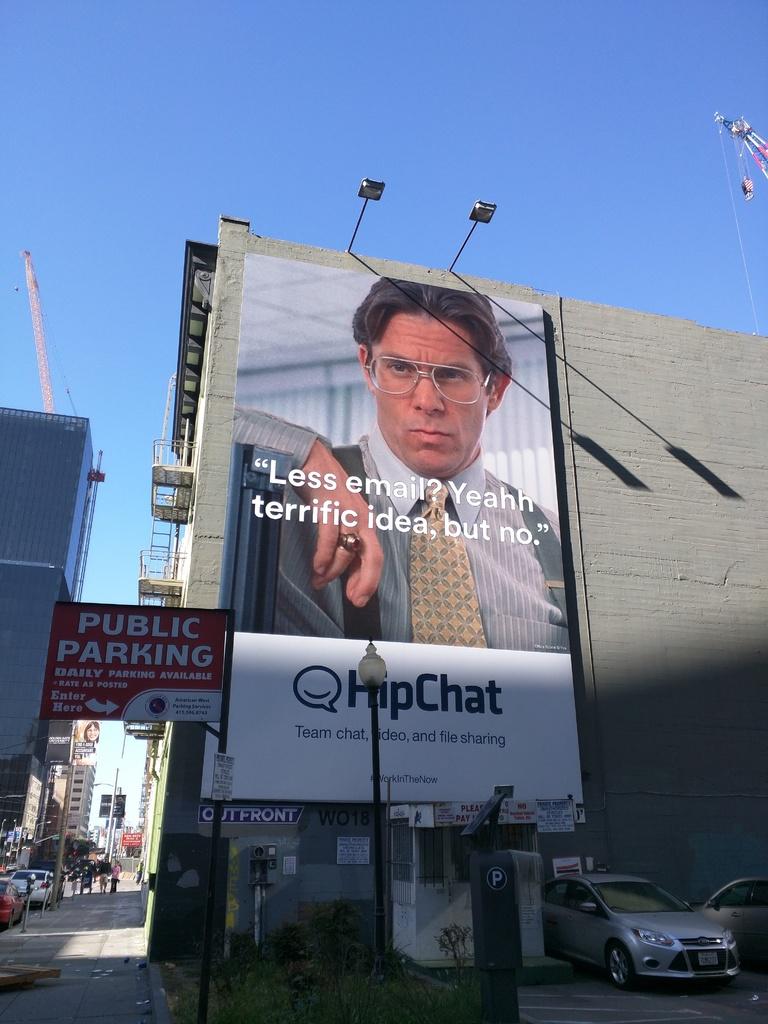Is there indication of public parking?
Offer a very short reply. Yes. 